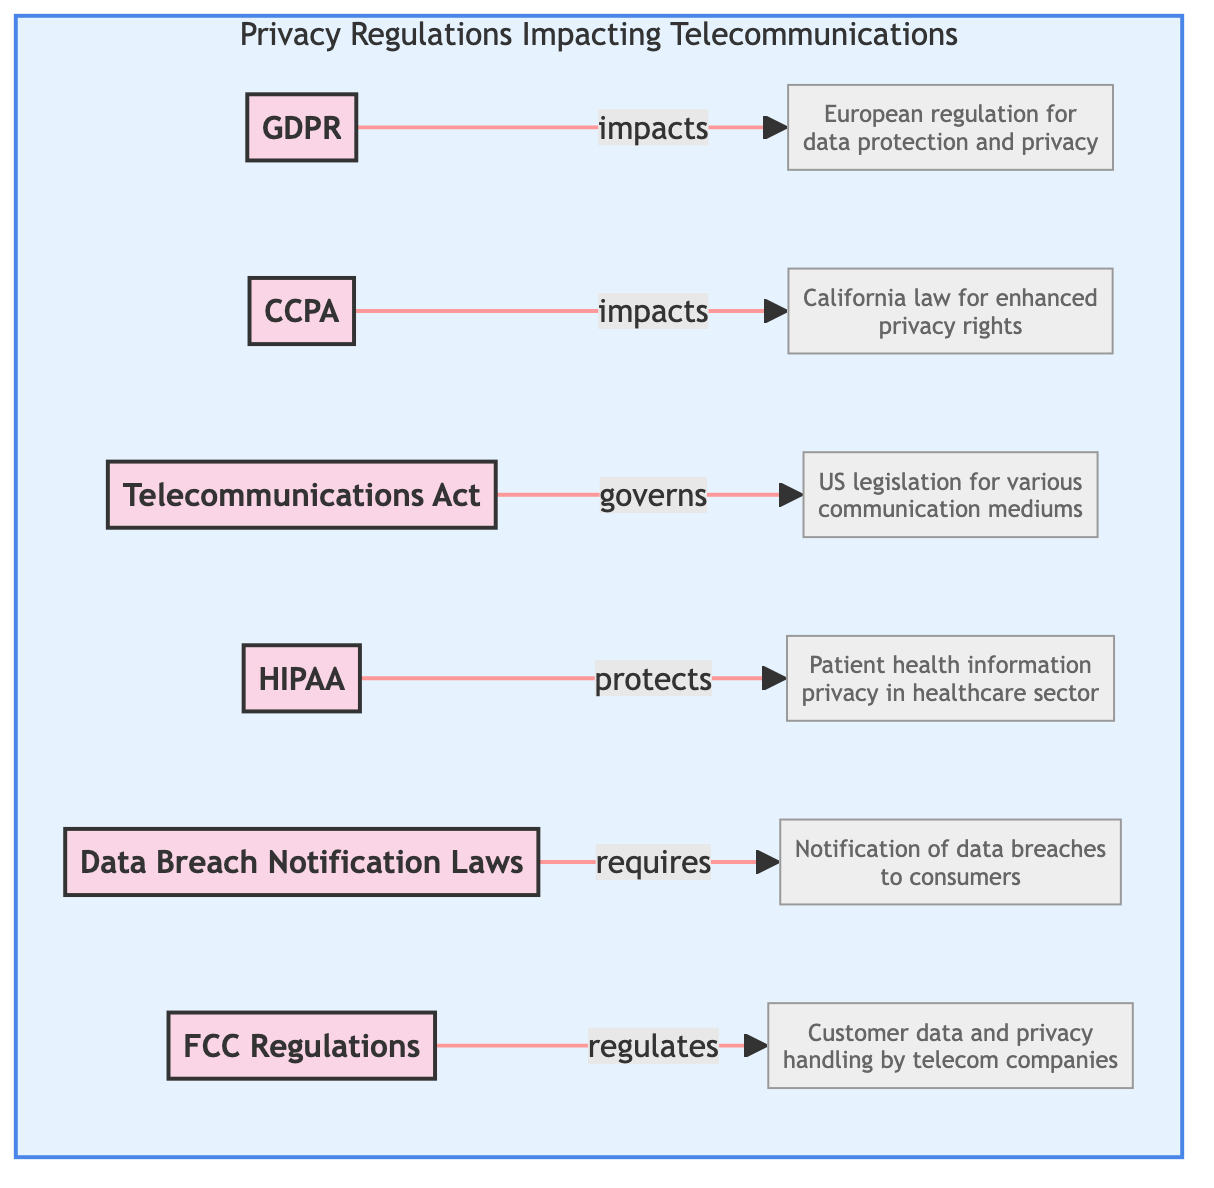What is GDPR? GDPR is described in the diagram as the European regulation that mandates strict guidelines on data protection and privacy for all individuals within the EU. The diagram specifically highlights this information in the description connected to the GDPR node.
Answer: European regulation that mandates strict guidelines on data protection and privacy for all individuals within the EU How many regulations are depicted in the diagram? The diagram shows a total of six different regulations impacting telecommunications companies, which can be counted from the nodes listed in the "Privacy Regulations Impacting Telecommunications" subgraph.
Answer: 6 What does CCPA enhance? According to the diagram, CCPA enhances privacy rights. This can be determined by looking at how the CCPA node connects to its description, which specifically states this enhancement.
Answer: Privacy rights Which regulation is related to patient health information? The HIPAA node refers to privacy protection specifically for patient health information. The relationship is clear as it is explicitly labeled in the description connected to the HIPAA node.
Answer: HIPAA Which regulation requires notification of data breaches? The Data Breach Notification Laws node in the diagram is described as requiring companies to notify consumers of data breaches. The connection between the node and its description clearly outlines this requirement.
Answer: Data Breach Notification Laws What does FCC regulate? The FCC Regulations node points to handling of customer data and privacy, as noted in the description. This connection explains the specific aspect of telecommunications that FCC regulations govern.
Answer: Customer data and privacy handling Which regulation governs communications by multiple mediums? The Telecommunications Act node in the diagram signifies that it governs communications by various mediums, including radio, television, wire, satellite, and cable. This is indicated in the description linked to the node.
Answer: Telecommunications Act What relationship does GDPR have with telecommunications? GDPR is shown to impact telecommunications by mandating guidelines on data protection and privacy, which applies to telecommunications' handling of user data in Europe. The diagram establishes this link clearly.
Answer: Impacts What is the main focus of HIPAA regarding telecommunications? The main focus of HIPAA, as represented in the diagram, is on protecting patient health information privacy specifically within the healthcare sector, and this is detailed in the description connected to the HIPAA node.
Answer: Patient health information privacy 